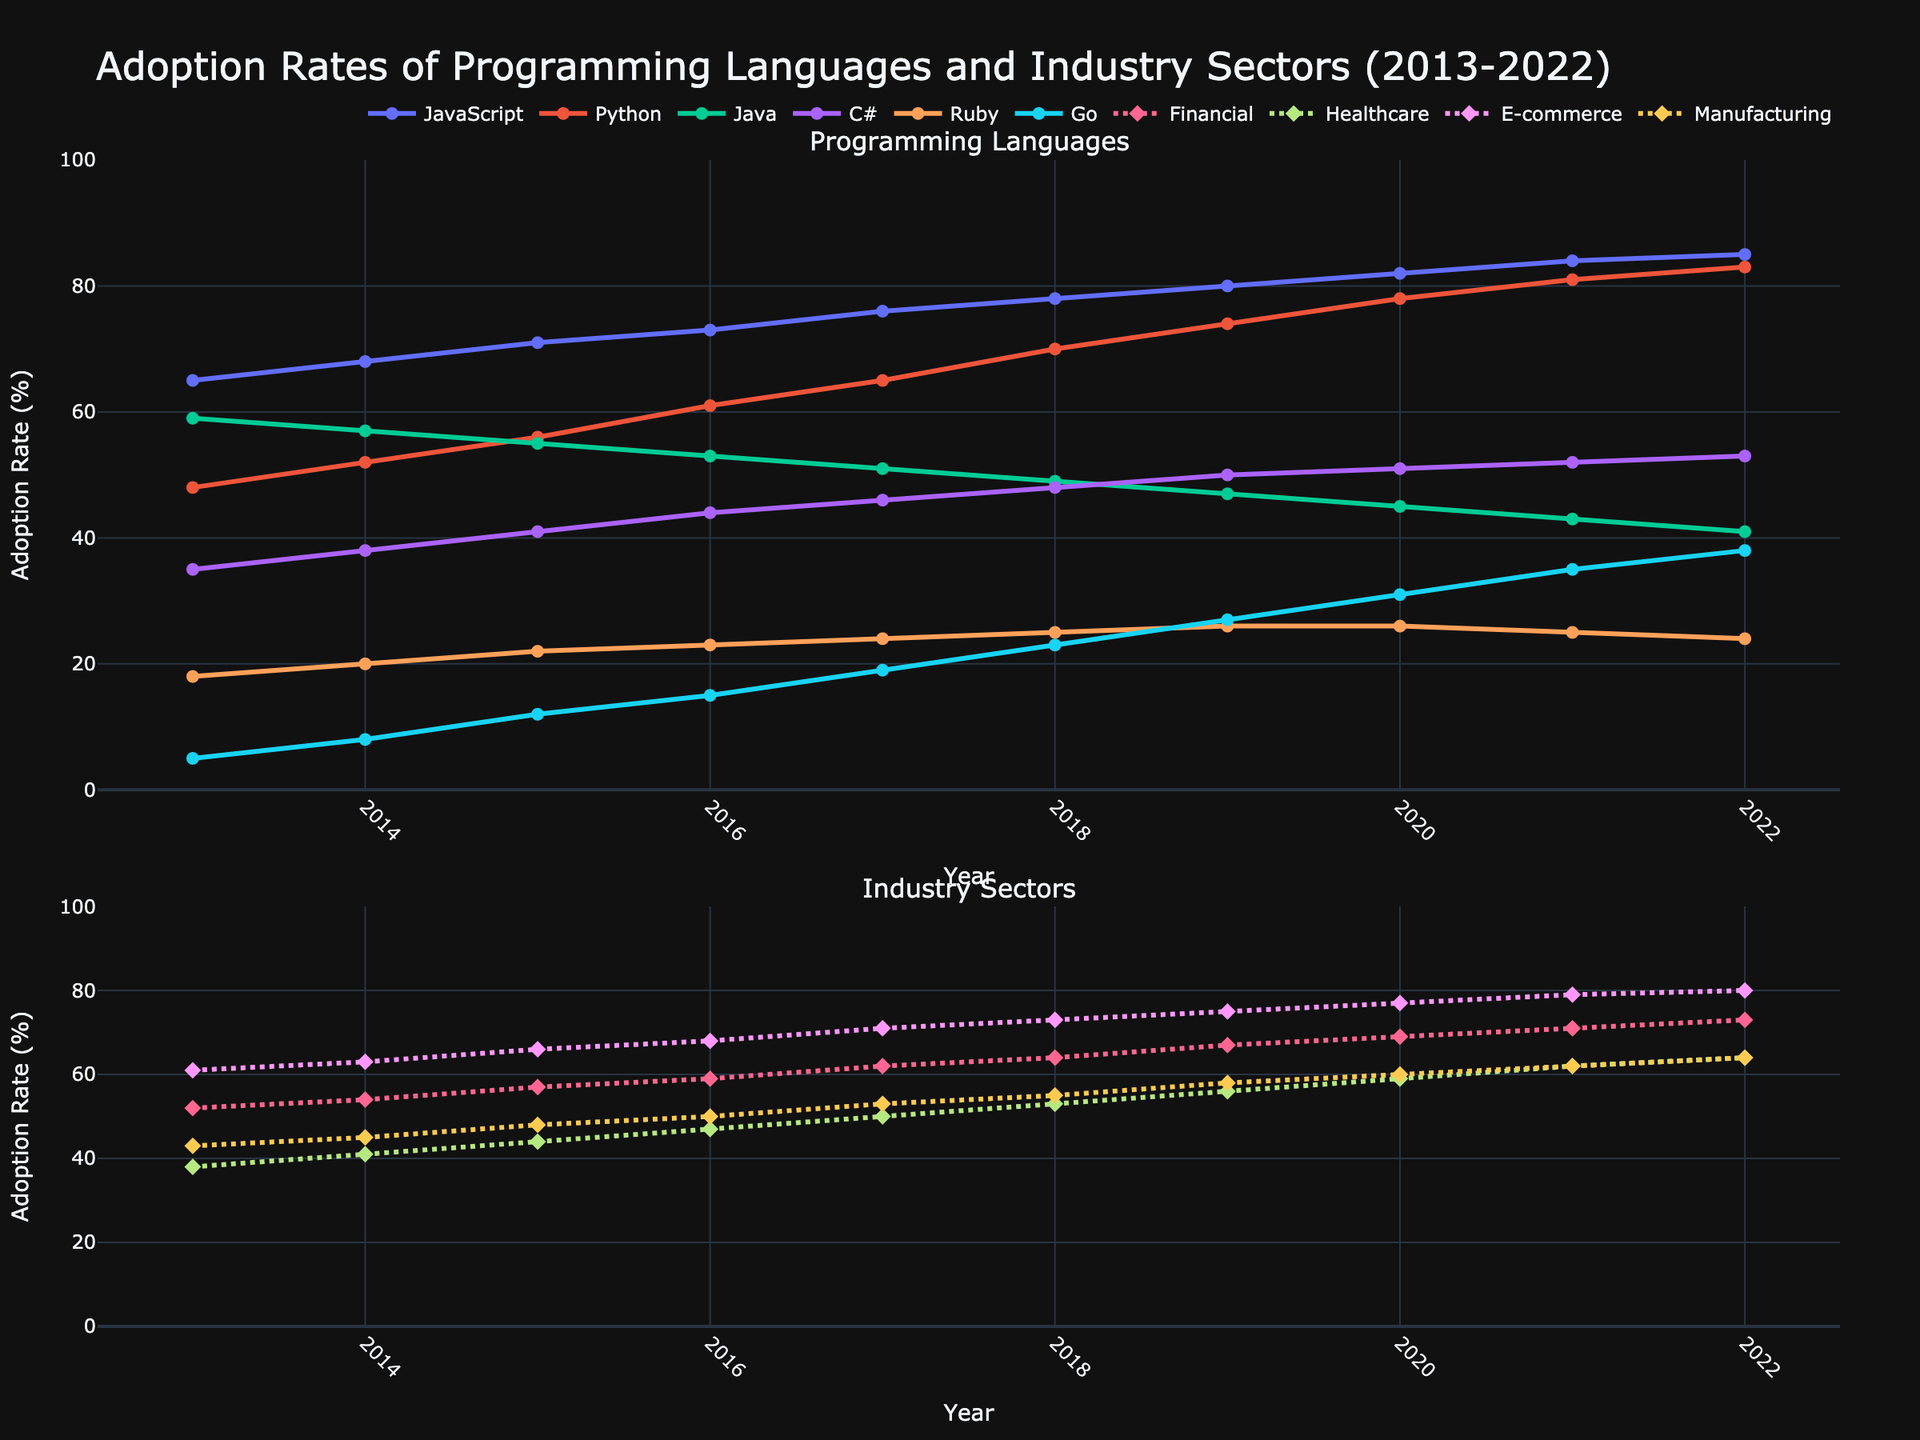What's the most adopted programming language in 2022? By observing the top graph's line height in 2022, the line for JavaScript reaches the highest adoption rate among the listed languages.
Answer: JavaScript Which industry sector had the lowest adoption rate in 2021? In the bottom graph for 2021, the line for the Manufacturing sector is the lowest compared to Financial, Healthcare, and E-commerce sectors.
Answer: Manufacturing What was the average adoption rate of C# from 2013 to 2022? Calculate the sum of C# rates over the years (35 + 38 + 41 + 44 + 46 + 48 + 50 + 51 + 52 + 53 = 458) and then divide by the number of years (10).
Answer: 45.8 Which year saw a tie in adoption rates between Go and Ruby, and what was the rate? By examining both graphs, in 2020, the lines for Go and Ruby intersect with both having an adoption rate of 26%.
Answer: 2020, 26% Did Healthcare or E-commerce see a larger increase in adoption rates from 2013 to 2022? Calculate the increase for each sector: Healthcare (64 - 38 = 26), E-commerce (80 - 61 = 19). Healthcare had a larger increase.
Answer: Healthcare How did the adoption rate of Python compare to JavaScript in 2019? In the top graph for 2019, the line for JavaScript (80%) is higher than the line for Python (74%).
Answer: JavaScript was higher Which programming language has the steadiest increase in adoption rate from 2013 to 2022? Examine the smoothness of the lines' slopes. Python's line steadily increases each year without dips or sudden spikes.
Answer: Python Calculate the total adoption rate for Financial and Healthcare sectors in 2015. Add the rates of Financial (57) and Healthcare (44) for 2015.
Answer: 101 Is there any year where Python's adoption rate nearly equals Java's? In 2014, Python's adoption rate was 52% and Java's was 57%, which are close in value.
Answer: 2014, nearly What visual pattern can be seen regarding the adoption rates for the Financial sector? The line for the Financial sector in the bottom graph shows a consistent increase year after year without any decline or plateauing.
Answer: Consistent increase 